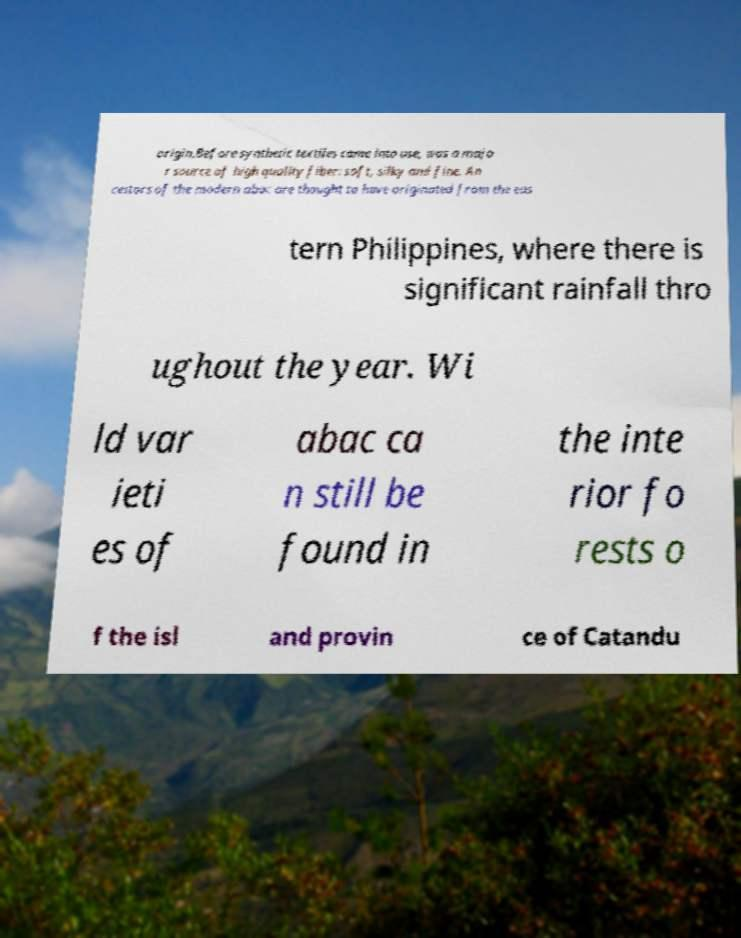Could you extract and type out the text from this image? origin.Before synthetic textiles came into use, was a majo r source of high quality fiber: soft, silky and fine. An cestors of the modern abac are thought to have originated from the eas tern Philippines, where there is significant rainfall thro ughout the year. Wi ld var ieti es of abac ca n still be found in the inte rior fo rests o f the isl and provin ce of Catandu 